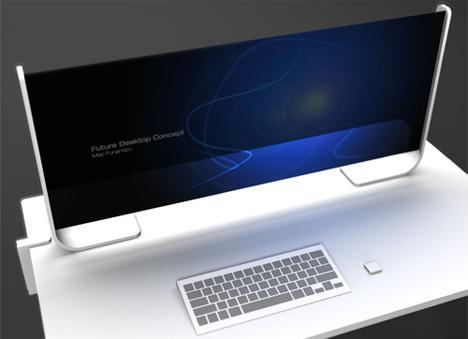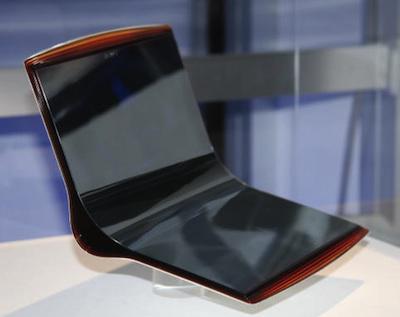The first image is the image on the left, the second image is the image on the right. For the images shown, is this caption "The computer in the image on the left has a grey base." true? Answer yes or no. Yes. 